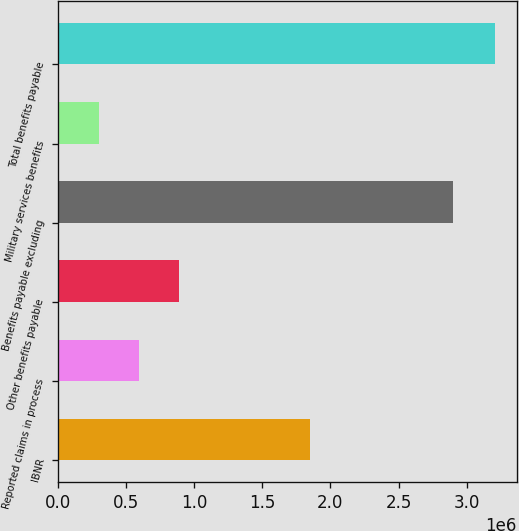Convert chart to OTSL. <chart><loc_0><loc_0><loc_500><loc_500><bar_chart><fcel>IBNR<fcel>Reported claims in process<fcel>Other benefits payable<fcel>Benefits payable excluding<fcel>Military services benefits<fcel>Total benefits payable<nl><fcel>1.85105e+06<fcel>596675<fcel>886553<fcel>2.89878e+06<fcel>306797<fcel>3.20558e+06<nl></chart> 